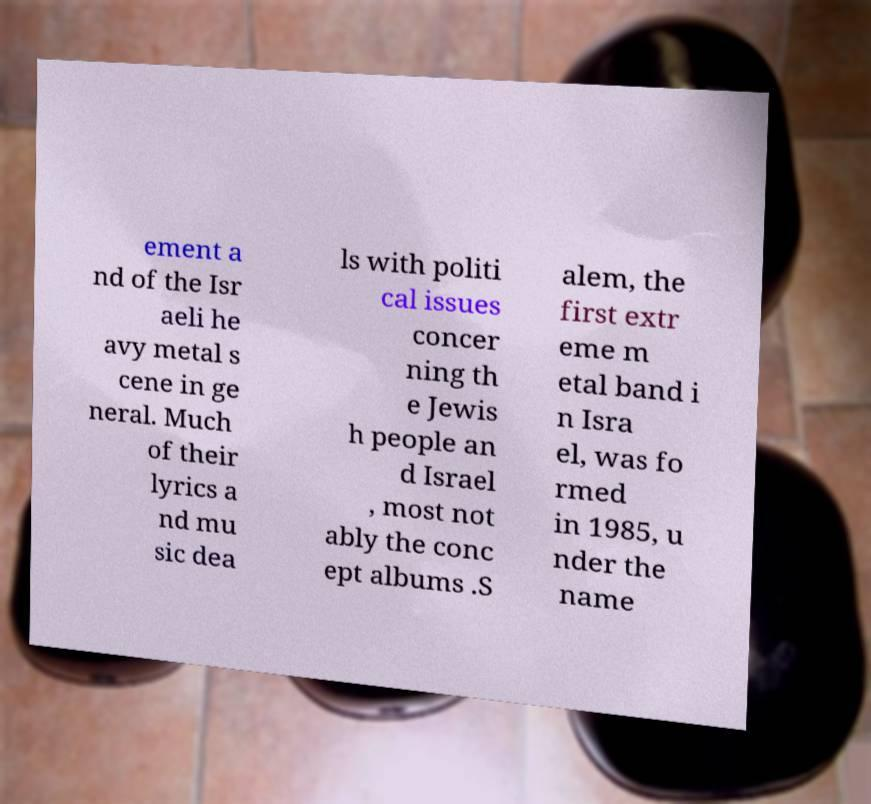Can you read and provide the text displayed in the image?This photo seems to have some interesting text. Can you extract and type it out for me? ement a nd of the Isr aeli he avy metal s cene in ge neral. Much of their lyrics a nd mu sic dea ls with politi cal issues concer ning th e Jewis h people an d Israel , most not ably the conc ept albums .S alem, the first extr eme m etal band i n Isra el, was fo rmed in 1985, u nder the name 